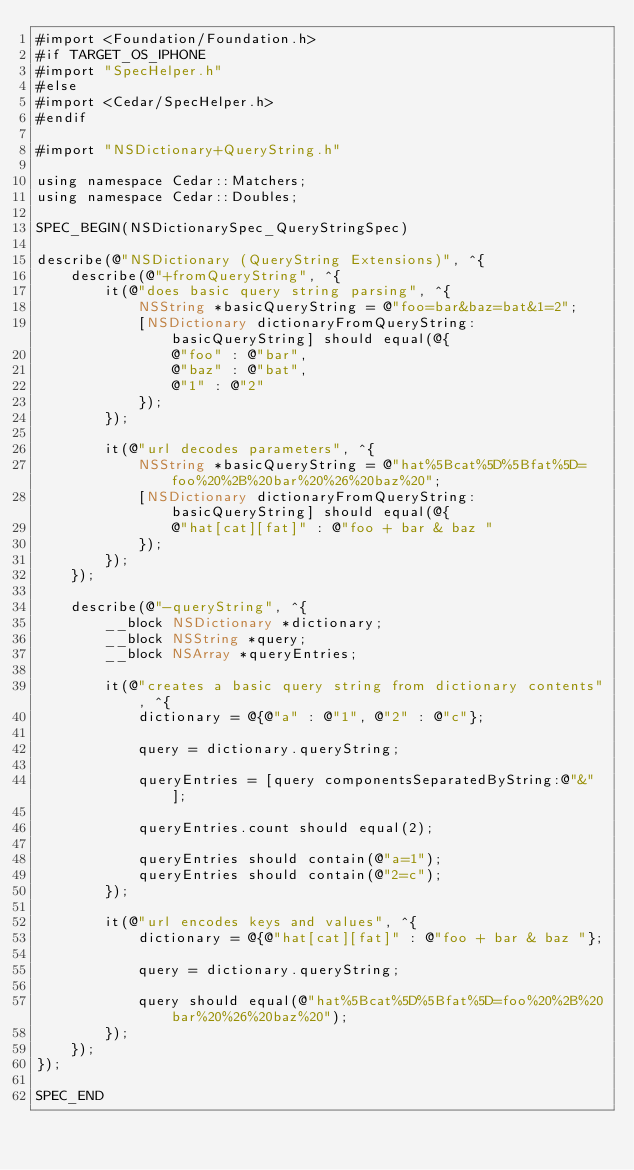Convert code to text. <code><loc_0><loc_0><loc_500><loc_500><_ObjectiveC_>#import <Foundation/Foundation.h>
#if TARGET_OS_IPHONE
#import "SpecHelper.h"
#else
#import <Cedar/SpecHelper.h>
#endif

#import "NSDictionary+QueryString.h"

using namespace Cedar::Matchers;
using namespace Cedar::Doubles;

SPEC_BEGIN(NSDictionarySpec_QueryStringSpec)

describe(@"NSDictionary (QueryString Extensions)", ^{
    describe(@"+fromQueryString", ^{
        it(@"does basic query string parsing", ^{
            NSString *basicQueryString = @"foo=bar&baz=bat&1=2";
            [NSDictionary dictionaryFromQueryString:basicQueryString] should equal(@{
                @"foo" : @"bar",
                @"baz" : @"bat",
                @"1" : @"2"
            });
        });

        it(@"url decodes parameters", ^{
            NSString *basicQueryString = @"hat%5Bcat%5D%5Bfat%5D=foo%20%2B%20bar%20%26%20baz%20";
            [NSDictionary dictionaryFromQueryString:basicQueryString] should equal(@{
                @"hat[cat][fat]" : @"foo + bar & baz "
            });
        });
    });

    describe(@"-queryString", ^{
        __block NSDictionary *dictionary;
        __block NSString *query;
        __block NSArray *queryEntries;

        it(@"creates a basic query string from dictionary contents", ^{
            dictionary = @{@"a" : @"1", @"2" : @"c"};

            query = dictionary.queryString;

            queryEntries = [query componentsSeparatedByString:@"&"];

            queryEntries.count should equal(2);

            queryEntries should contain(@"a=1");
            queryEntries should contain(@"2=c");
        });

        it(@"url encodes keys and values", ^{
            dictionary = @{@"hat[cat][fat]" : @"foo + bar & baz "};

            query = dictionary.queryString;

            query should equal(@"hat%5Bcat%5D%5Bfat%5D=foo%20%2B%20bar%20%26%20baz%20");
        });
    });
});

SPEC_END
</code> 